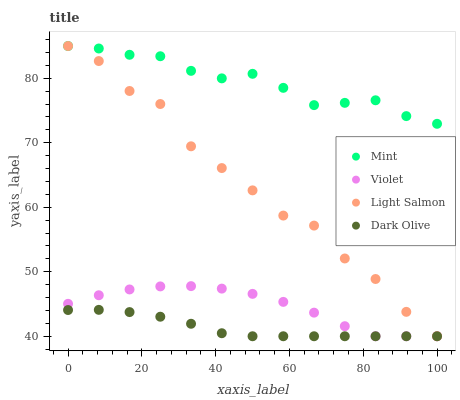Does Dark Olive have the minimum area under the curve?
Answer yes or no. Yes. Does Mint have the maximum area under the curve?
Answer yes or no. Yes. Does Mint have the minimum area under the curve?
Answer yes or no. No. Does Dark Olive have the maximum area under the curve?
Answer yes or no. No. Is Dark Olive the smoothest?
Answer yes or no. Yes. Is Light Salmon the roughest?
Answer yes or no. Yes. Is Mint the smoothest?
Answer yes or no. No. Is Mint the roughest?
Answer yes or no. No. Does Light Salmon have the lowest value?
Answer yes or no. Yes. Does Mint have the lowest value?
Answer yes or no. No. Does Mint have the highest value?
Answer yes or no. Yes. Does Dark Olive have the highest value?
Answer yes or no. No. Is Dark Olive less than Mint?
Answer yes or no. Yes. Is Mint greater than Dark Olive?
Answer yes or no. Yes. Does Mint intersect Light Salmon?
Answer yes or no. Yes. Is Mint less than Light Salmon?
Answer yes or no. No. Is Mint greater than Light Salmon?
Answer yes or no. No. Does Dark Olive intersect Mint?
Answer yes or no. No. 